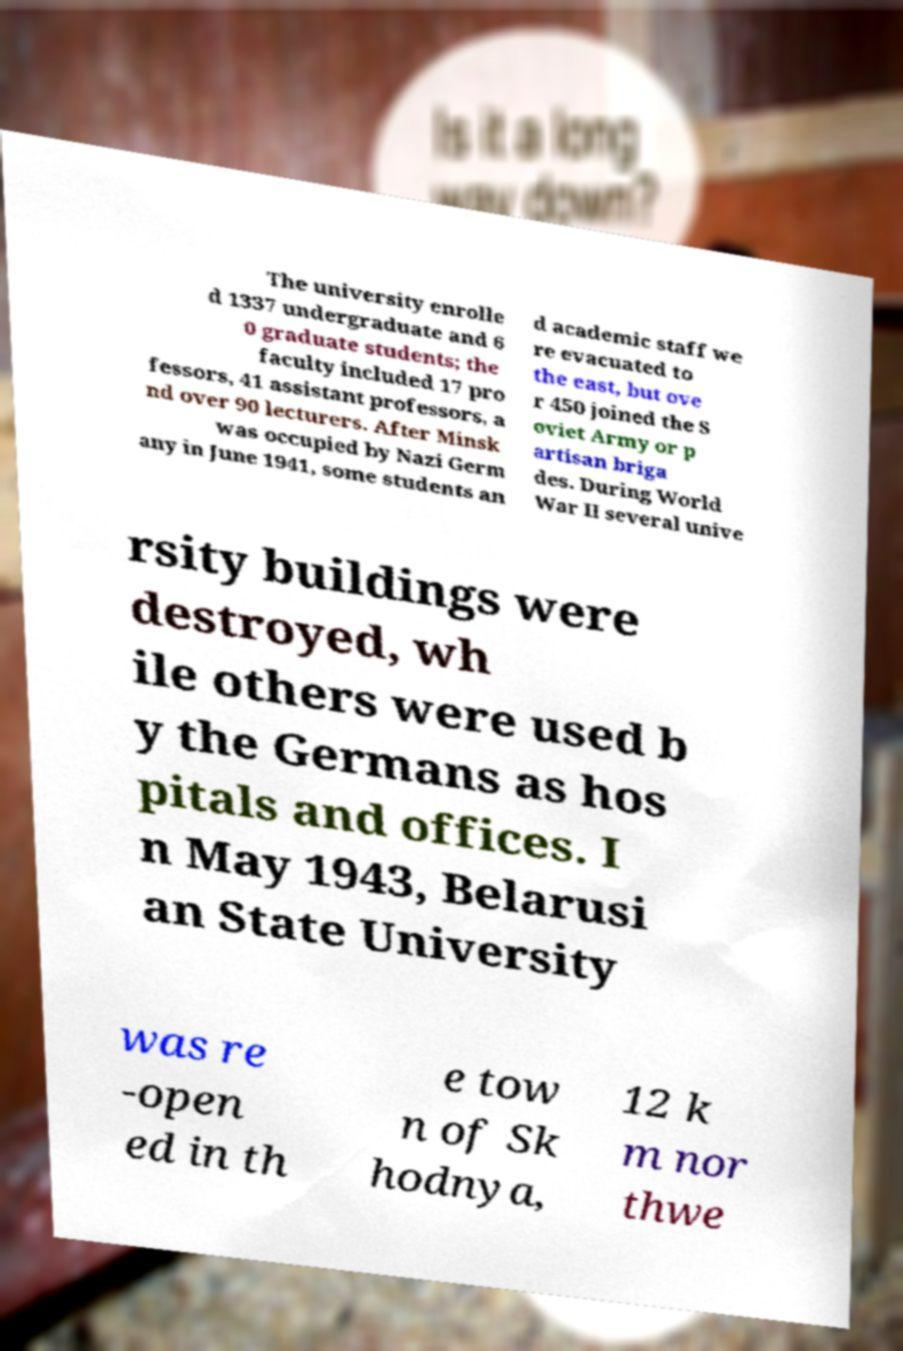Please read and relay the text visible in this image. What does it say? The university enrolle d 1337 undergraduate and 6 0 graduate students; the faculty included 17 pro fessors, 41 assistant professors, a nd over 90 lecturers. After Minsk was occupied by Nazi Germ any in June 1941, some students an d academic staff we re evacuated to the east, but ove r 450 joined the S oviet Army or p artisan briga des. During World War II several unive rsity buildings were destroyed, wh ile others were used b y the Germans as hos pitals and offices. I n May 1943, Belarusi an State University was re -open ed in th e tow n of Sk hodnya, 12 k m nor thwe 